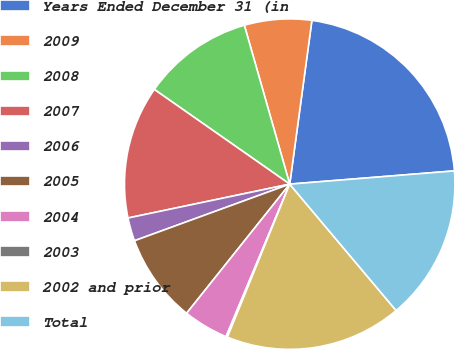Convert chart. <chart><loc_0><loc_0><loc_500><loc_500><pie_chart><fcel>Years Ended December 31 (in<fcel>2009<fcel>2008<fcel>2007<fcel>2006<fcel>2005<fcel>2004<fcel>2003<fcel>2002 and prior<fcel>Total<nl><fcel>21.58%<fcel>6.57%<fcel>10.86%<fcel>13.0%<fcel>2.28%<fcel>8.71%<fcel>4.43%<fcel>0.14%<fcel>17.29%<fcel>15.14%<nl></chart> 